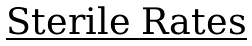Convert formula to latex. <formula><loc_0><loc_0><loc_500><loc_500>\text {\underline{Sterile Rates}}</formula> 